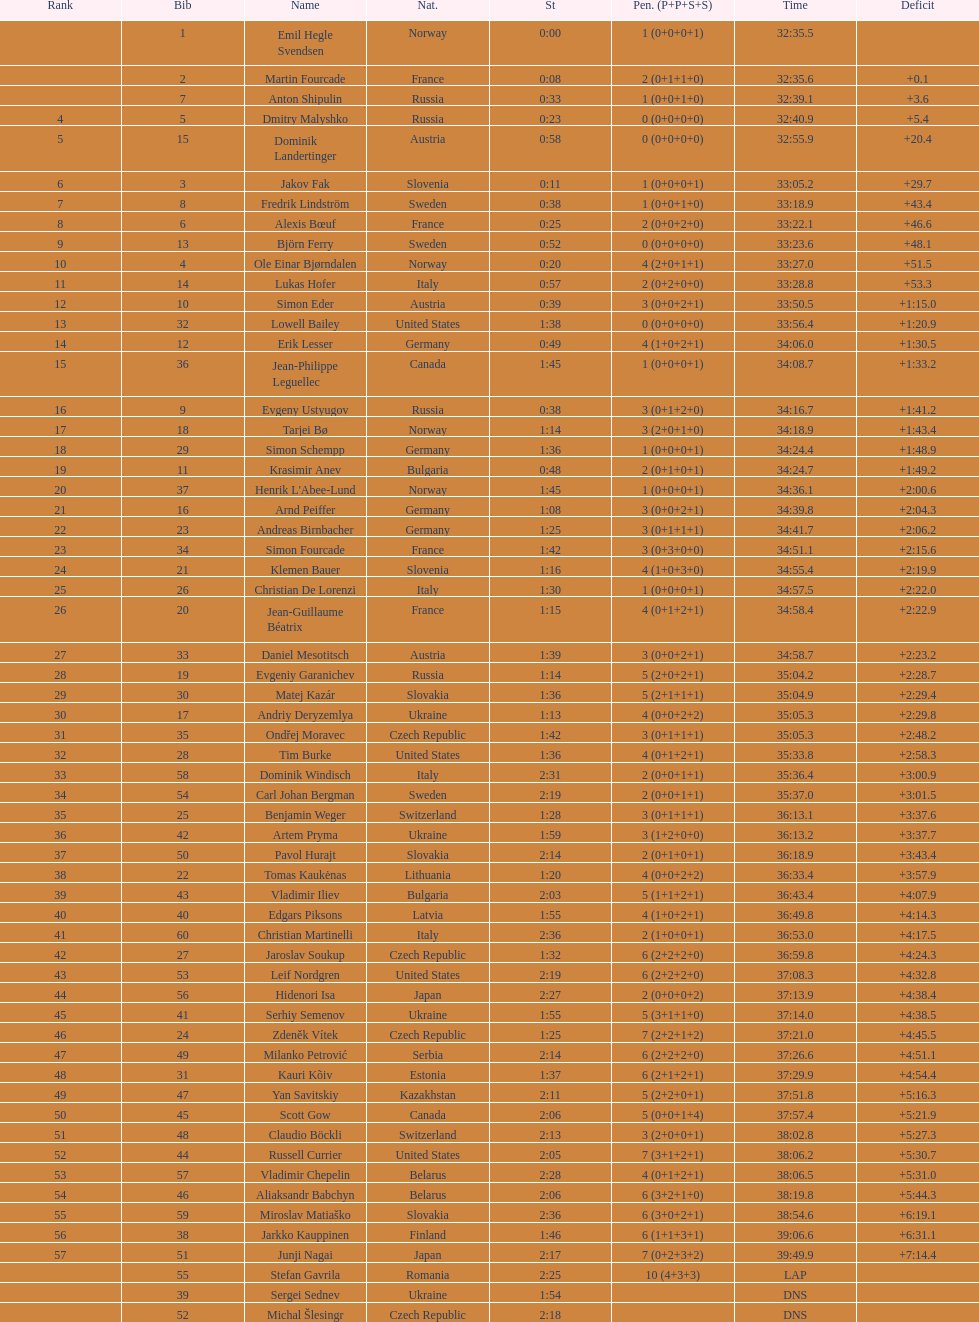Parse the full table. {'header': ['Rank', 'Bib', 'Name', 'Nat.', 'St', 'Pen. (P+P+S+S)', 'Time', 'Deficit'], 'rows': [['', '1', 'Emil Hegle Svendsen', 'Norway', '0:00', '1 (0+0+0+1)', '32:35.5', ''], ['', '2', 'Martin Fourcade', 'France', '0:08', '2 (0+1+1+0)', '32:35.6', '+0.1'], ['', '7', 'Anton Shipulin', 'Russia', '0:33', '1 (0+0+1+0)', '32:39.1', '+3.6'], ['4', '5', 'Dmitry Malyshko', 'Russia', '0:23', '0 (0+0+0+0)', '32:40.9', '+5.4'], ['5', '15', 'Dominik Landertinger', 'Austria', '0:58', '0 (0+0+0+0)', '32:55.9', '+20.4'], ['6', '3', 'Jakov Fak', 'Slovenia', '0:11', '1 (0+0+0+1)', '33:05.2', '+29.7'], ['7', '8', 'Fredrik Lindström', 'Sweden', '0:38', '1 (0+0+1+0)', '33:18.9', '+43.4'], ['8', '6', 'Alexis Bœuf', 'France', '0:25', '2 (0+0+2+0)', '33:22.1', '+46.6'], ['9', '13', 'Björn Ferry', 'Sweden', '0:52', '0 (0+0+0+0)', '33:23.6', '+48.1'], ['10', '4', 'Ole Einar Bjørndalen', 'Norway', '0:20', '4 (2+0+1+1)', '33:27.0', '+51.5'], ['11', '14', 'Lukas Hofer', 'Italy', '0:57', '2 (0+2+0+0)', '33:28.8', '+53.3'], ['12', '10', 'Simon Eder', 'Austria', '0:39', '3 (0+0+2+1)', '33:50.5', '+1:15.0'], ['13', '32', 'Lowell Bailey', 'United States', '1:38', '0 (0+0+0+0)', '33:56.4', '+1:20.9'], ['14', '12', 'Erik Lesser', 'Germany', '0:49', '4 (1+0+2+1)', '34:06.0', '+1:30.5'], ['15', '36', 'Jean-Philippe Leguellec', 'Canada', '1:45', '1 (0+0+0+1)', '34:08.7', '+1:33.2'], ['16', '9', 'Evgeny Ustyugov', 'Russia', '0:38', '3 (0+1+2+0)', '34:16.7', '+1:41.2'], ['17', '18', 'Tarjei Bø', 'Norway', '1:14', '3 (2+0+1+0)', '34:18.9', '+1:43.4'], ['18', '29', 'Simon Schempp', 'Germany', '1:36', '1 (0+0+0+1)', '34:24.4', '+1:48.9'], ['19', '11', 'Krasimir Anev', 'Bulgaria', '0:48', '2 (0+1+0+1)', '34:24.7', '+1:49.2'], ['20', '37', "Henrik L'Abee-Lund", 'Norway', '1:45', '1 (0+0+0+1)', '34:36.1', '+2:00.6'], ['21', '16', 'Arnd Peiffer', 'Germany', '1:08', '3 (0+0+2+1)', '34:39.8', '+2:04.3'], ['22', '23', 'Andreas Birnbacher', 'Germany', '1:25', '3 (0+1+1+1)', '34:41.7', '+2:06.2'], ['23', '34', 'Simon Fourcade', 'France', '1:42', '3 (0+3+0+0)', '34:51.1', '+2:15.6'], ['24', '21', 'Klemen Bauer', 'Slovenia', '1:16', '4 (1+0+3+0)', '34:55.4', '+2:19.9'], ['25', '26', 'Christian De Lorenzi', 'Italy', '1:30', '1 (0+0+0+1)', '34:57.5', '+2:22.0'], ['26', '20', 'Jean-Guillaume Béatrix', 'France', '1:15', '4 (0+1+2+1)', '34:58.4', '+2:22.9'], ['27', '33', 'Daniel Mesotitsch', 'Austria', '1:39', '3 (0+0+2+1)', '34:58.7', '+2:23.2'], ['28', '19', 'Evgeniy Garanichev', 'Russia', '1:14', '5 (2+0+2+1)', '35:04.2', '+2:28.7'], ['29', '30', 'Matej Kazár', 'Slovakia', '1:36', '5 (2+1+1+1)', '35:04.9', '+2:29.4'], ['30', '17', 'Andriy Deryzemlya', 'Ukraine', '1:13', '4 (0+0+2+2)', '35:05.3', '+2:29.8'], ['31', '35', 'Ondřej Moravec', 'Czech Republic', '1:42', '3 (0+1+1+1)', '35:05.3', '+2:48.2'], ['32', '28', 'Tim Burke', 'United States', '1:36', '4 (0+1+2+1)', '35:33.8', '+2:58.3'], ['33', '58', 'Dominik Windisch', 'Italy', '2:31', '2 (0+0+1+1)', '35:36.4', '+3:00.9'], ['34', '54', 'Carl Johan Bergman', 'Sweden', '2:19', '2 (0+0+1+1)', '35:37.0', '+3:01.5'], ['35', '25', 'Benjamin Weger', 'Switzerland', '1:28', '3 (0+1+1+1)', '36:13.1', '+3:37.6'], ['36', '42', 'Artem Pryma', 'Ukraine', '1:59', '3 (1+2+0+0)', '36:13.2', '+3:37.7'], ['37', '50', 'Pavol Hurajt', 'Slovakia', '2:14', '2 (0+1+0+1)', '36:18.9', '+3:43.4'], ['38', '22', 'Tomas Kaukėnas', 'Lithuania', '1:20', '4 (0+0+2+2)', '36:33.4', '+3:57.9'], ['39', '43', 'Vladimir Iliev', 'Bulgaria', '2:03', '5 (1+1+2+1)', '36:43.4', '+4:07.9'], ['40', '40', 'Edgars Piksons', 'Latvia', '1:55', '4 (1+0+2+1)', '36:49.8', '+4:14.3'], ['41', '60', 'Christian Martinelli', 'Italy', '2:36', '2 (1+0+0+1)', '36:53.0', '+4:17.5'], ['42', '27', 'Jaroslav Soukup', 'Czech Republic', '1:32', '6 (2+2+2+0)', '36:59.8', '+4:24.3'], ['43', '53', 'Leif Nordgren', 'United States', '2:19', '6 (2+2+2+0)', '37:08.3', '+4:32.8'], ['44', '56', 'Hidenori Isa', 'Japan', '2:27', '2 (0+0+0+2)', '37:13.9', '+4:38.4'], ['45', '41', 'Serhiy Semenov', 'Ukraine', '1:55', '5 (3+1+1+0)', '37:14.0', '+4:38.5'], ['46', '24', 'Zdeněk Vítek', 'Czech Republic', '1:25', '7 (2+2+1+2)', '37:21.0', '+4:45.5'], ['47', '49', 'Milanko Petrović', 'Serbia', '2:14', '6 (2+2+2+0)', '37:26.6', '+4:51.1'], ['48', '31', 'Kauri Kõiv', 'Estonia', '1:37', '6 (2+1+2+1)', '37:29.9', '+4:54.4'], ['49', '47', 'Yan Savitskiy', 'Kazakhstan', '2:11', '5 (2+2+0+1)', '37:51.8', '+5:16.3'], ['50', '45', 'Scott Gow', 'Canada', '2:06', '5 (0+0+1+4)', '37:57.4', '+5:21.9'], ['51', '48', 'Claudio Böckli', 'Switzerland', '2:13', '3 (2+0+0+1)', '38:02.8', '+5:27.3'], ['52', '44', 'Russell Currier', 'United States', '2:05', '7 (3+1+2+1)', '38:06.2', '+5:30.7'], ['53', '57', 'Vladimir Chepelin', 'Belarus', '2:28', '4 (0+1+2+1)', '38:06.5', '+5:31.0'], ['54', '46', 'Aliaksandr Babchyn', 'Belarus', '2:06', '6 (3+2+1+0)', '38:19.8', '+5:44.3'], ['55', '59', 'Miroslav Matiaško', 'Slovakia', '2:36', '6 (3+0+2+1)', '38:54.6', '+6:19.1'], ['56', '38', 'Jarkko Kauppinen', 'Finland', '1:46', '6 (1+1+3+1)', '39:06.6', '+6:31.1'], ['57', '51', 'Junji Nagai', 'Japan', '2:17', '7 (0+2+3+2)', '39:49.9', '+7:14.4'], ['', '55', 'Stefan Gavrila', 'Romania', '2:25', '10 (4+3+3)', 'LAP', ''], ['', '39', 'Sergei Sednev', 'Ukraine', '1:54', '', 'DNS', ''], ['', '52', 'Michal Šlesingr', 'Czech Republic', '2:18', '', 'DNS', '']]} How long did it take for erik lesser to finish? 34:06.0. 